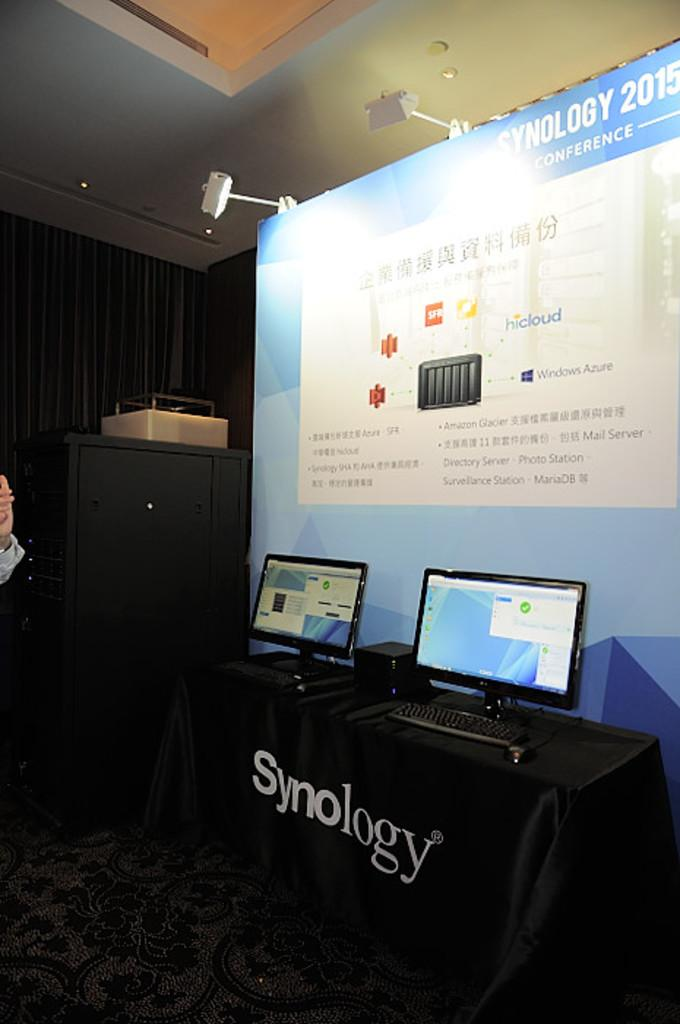<image>
Share a concise interpretation of the image provided. A table with laptops on it and a table cloth with Synology on it. 